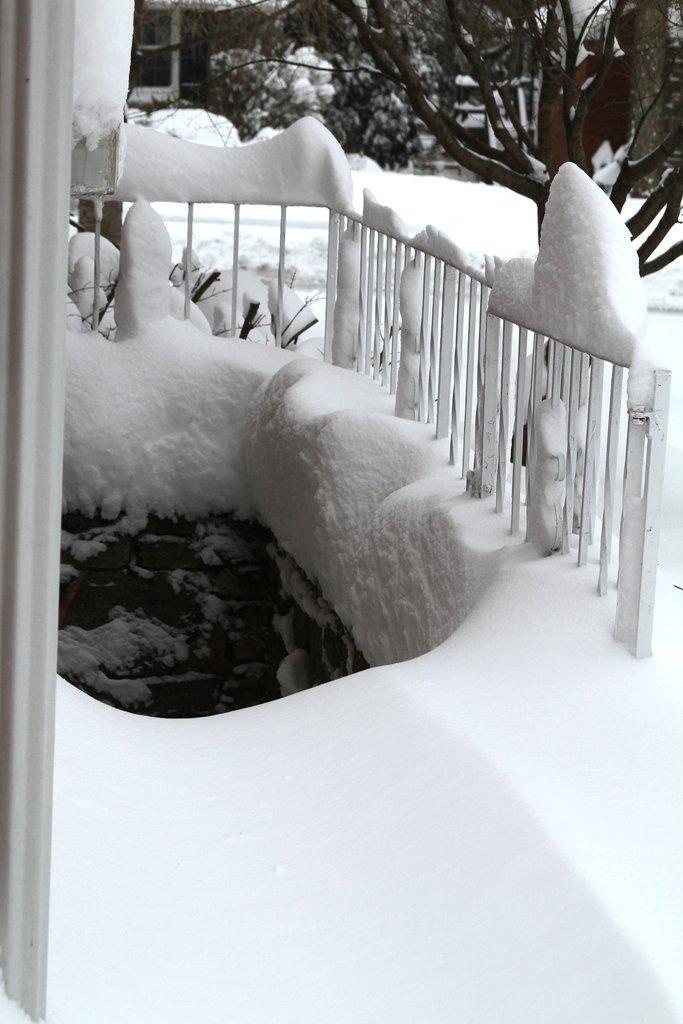Describe this image in one or two sentences. In this picture there is a boundary on the right side of the image and there is snow around the area of the image, there are trees at the top side of the image. 